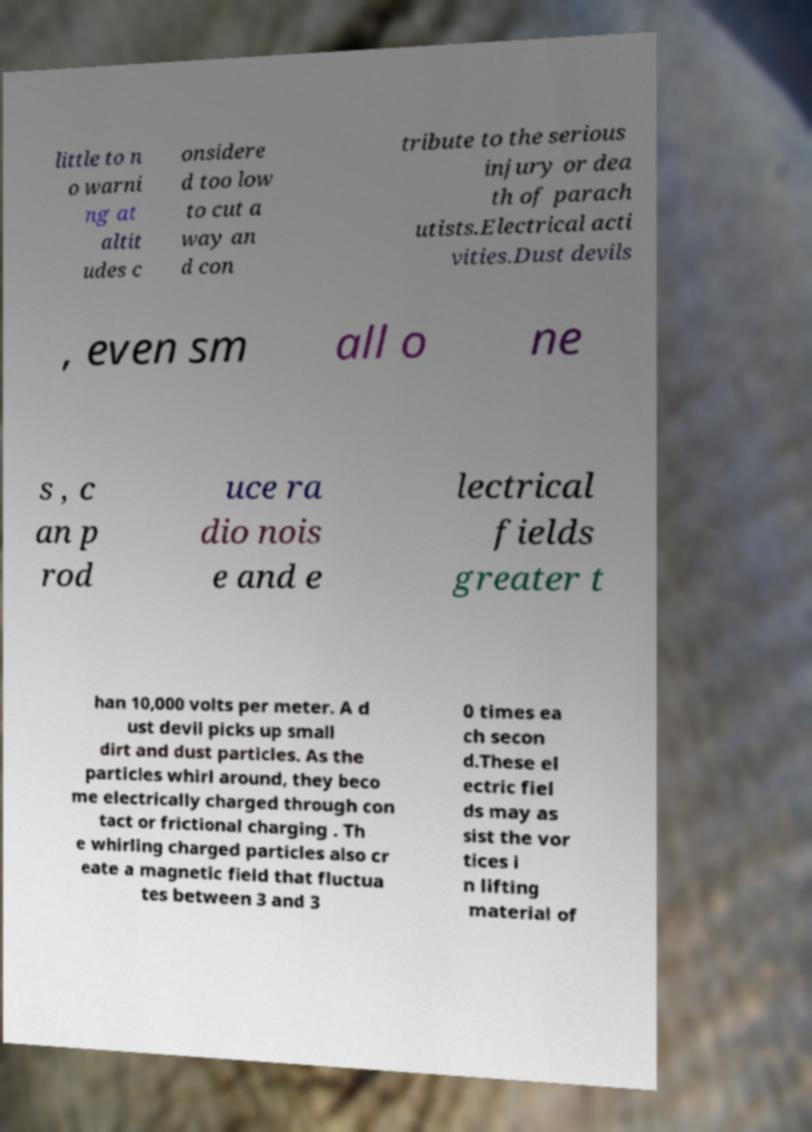Can you accurately transcribe the text from the provided image for me? little to n o warni ng at altit udes c onsidere d too low to cut a way an d con tribute to the serious injury or dea th of parach utists.Electrical acti vities.Dust devils , even sm all o ne s , c an p rod uce ra dio nois e and e lectrical fields greater t han 10,000 volts per meter. A d ust devil picks up small dirt and dust particles. As the particles whirl around, they beco me electrically charged through con tact or frictional charging . Th e whirling charged particles also cr eate a magnetic field that fluctua tes between 3 and 3 0 times ea ch secon d.These el ectric fiel ds may as sist the vor tices i n lifting material of 